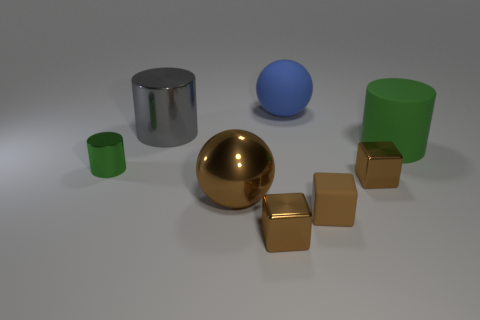Subtract all green cylinders. How many cylinders are left? 1 Subtract all balls. How many objects are left? 6 Add 2 small brown metal spheres. How many objects exist? 10 Subtract all blue balls. How many balls are left? 1 Subtract all rubber objects. Subtract all gray objects. How many objects are left? 4 Add 5 tiny shiny cylinders. How many tiny shiny cylinders are left? 6 Add 4 yellow metal cylinders. How many yellow metal cylinders exist? 4 Subtract 2 brown cubes. How many objects are left? 6 Subtract 1 spheres. How many spheres are left? 1 Subtract all brown cylinders. Subtract all yellow spheres. How many cylinders are left? 3 